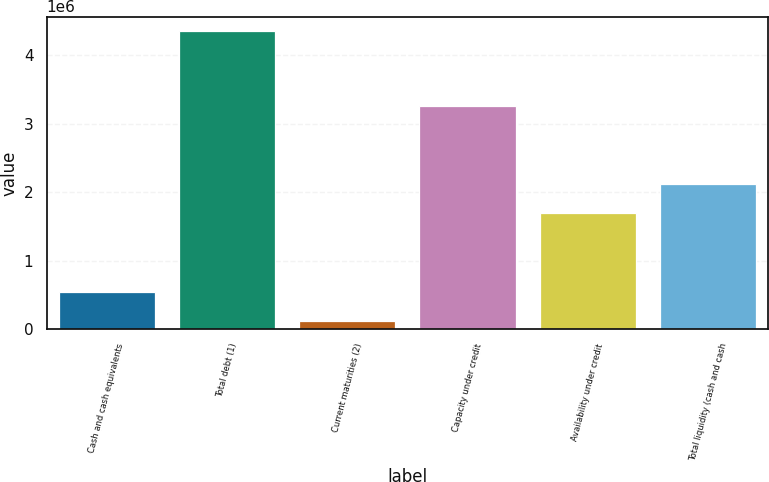Convert chart. <chart><loc_0><loc_0><loc_500><loc_500><bar_chart><fcel>Cash and cash equivalents<fcel>Total debt (1)<fcel>Current maturities (2)<fcel>Capacity under credit<fcel>Availability under credit<fcel>Total liquidity (cash and cash<nl><fcel>544675<fcel>4.3477e+06<fcel>122117<fcel>3.26e+06<fcel>1.6977e+06<fcel>2.12026e+06<nl></chart> 